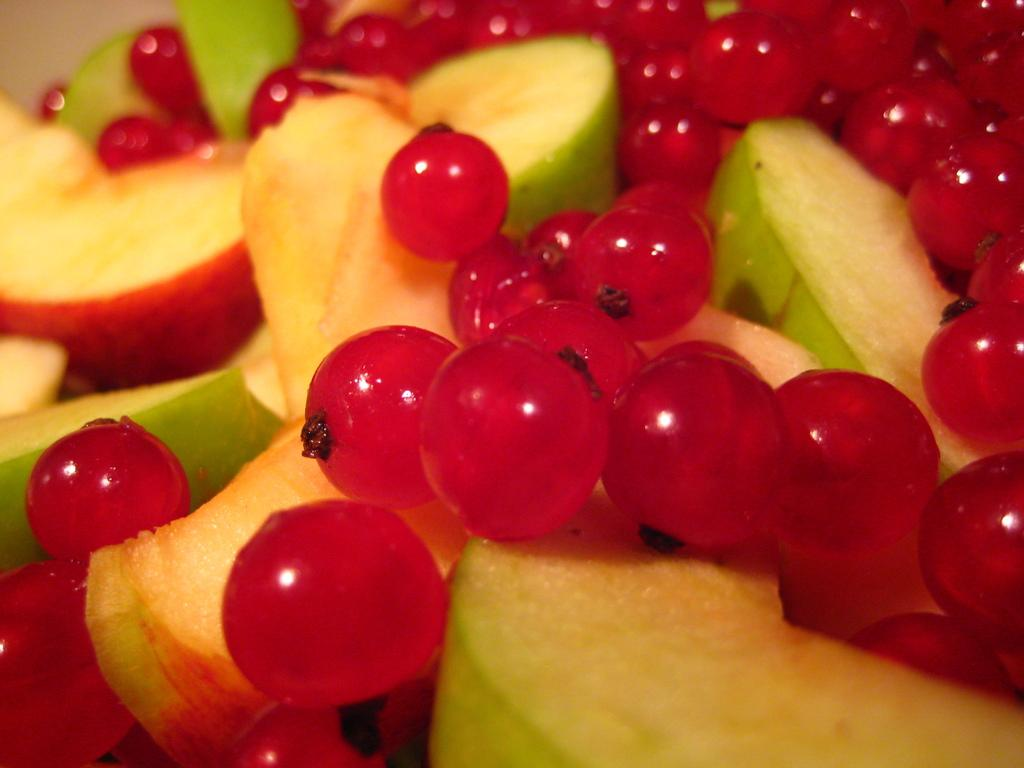What type of food is present in the image? There are fruits in the image. What specific fruits can be seen in the image? The fruits include apples and cherries. What is the number of things that can be seen in the image? The question is too vague to answer definitively, as it does not specify what "things" are being referred to. However, we can say that there are at least two types of fruits (apples and cherries) visible in the image. 